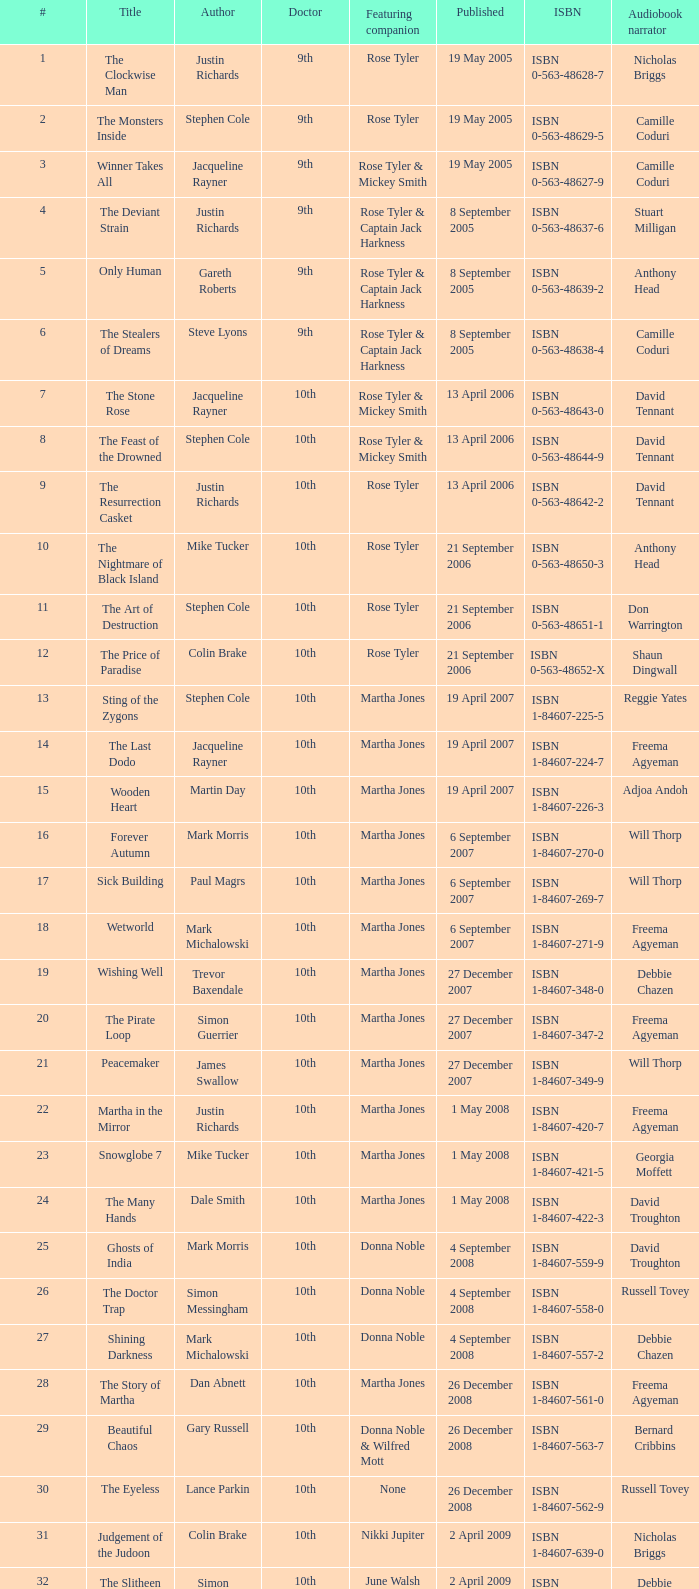What is the publication date of the book that is narrated by Michael Maloney? 29 September 2011. 